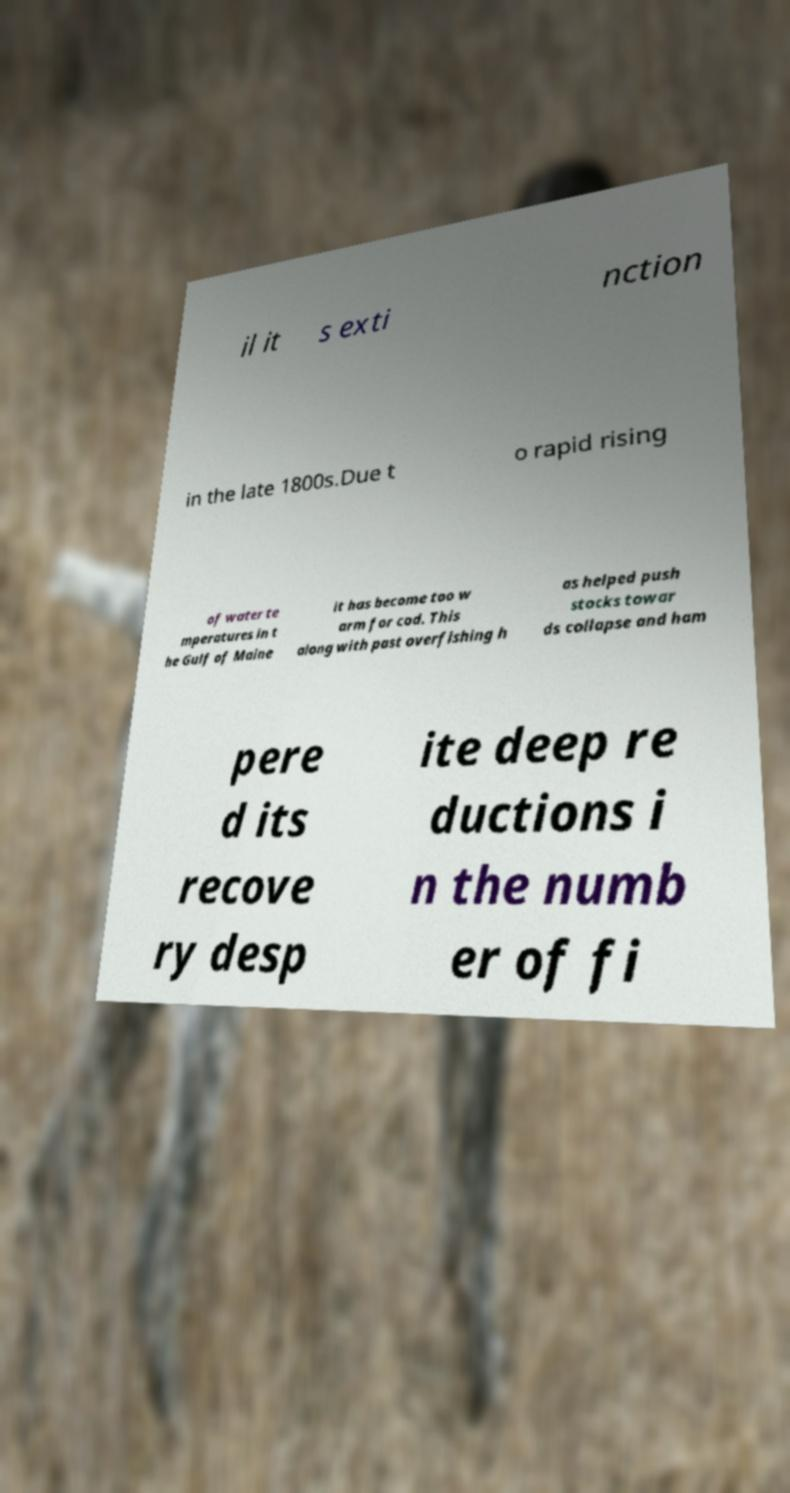For documentation purposes, I need the text within this image transcribed. Could you provide that? il it s exti nction in the late 1800s.Due t o rapid rising of water te mperatures in t he Gulf of Maine it has become too w arm for cod. This along with past overfishing h as helped push stocks towar ds collapse and ham pere d its recove ry desp ite deep re ductions i n the numb er of fi 